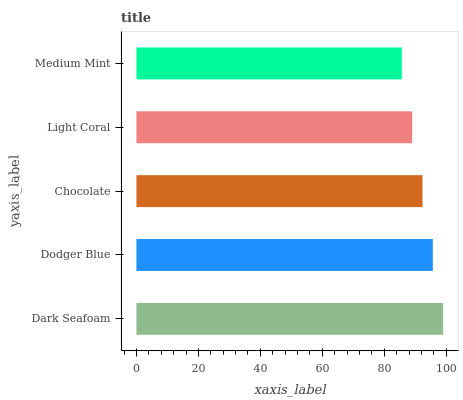Is Medium Mint the minimum?
Answer yes or no. Yes. Is Dark Seafoam the maximum?
Answer yes or no. Yes. Is Dodger Blue the minimum?
Answer yes or no. No. Is Dodger Blue the maximum?
Answer yes or no. No. Is Dark Seafoam greater than Dodger Blue?
Answer yes or no. Yes. Is Dodger Blue less than Dark Seafoam?
Answer yes or no. Yes. Is Dodger Blue greater than Dark Seafoam?
Answer yes or no. No. Is Dark Seafoam less than Dodger Blue?
Answer yes or no. No. Is Chocolate the high median?
Answer yes or no. Yes. Is Chocolate the low median?
Answer yes or no. Yes. Is Dodger Blue the high median?
Answer yes or no. No. Is Light Coral the low median?
Answer yes or no. No. 